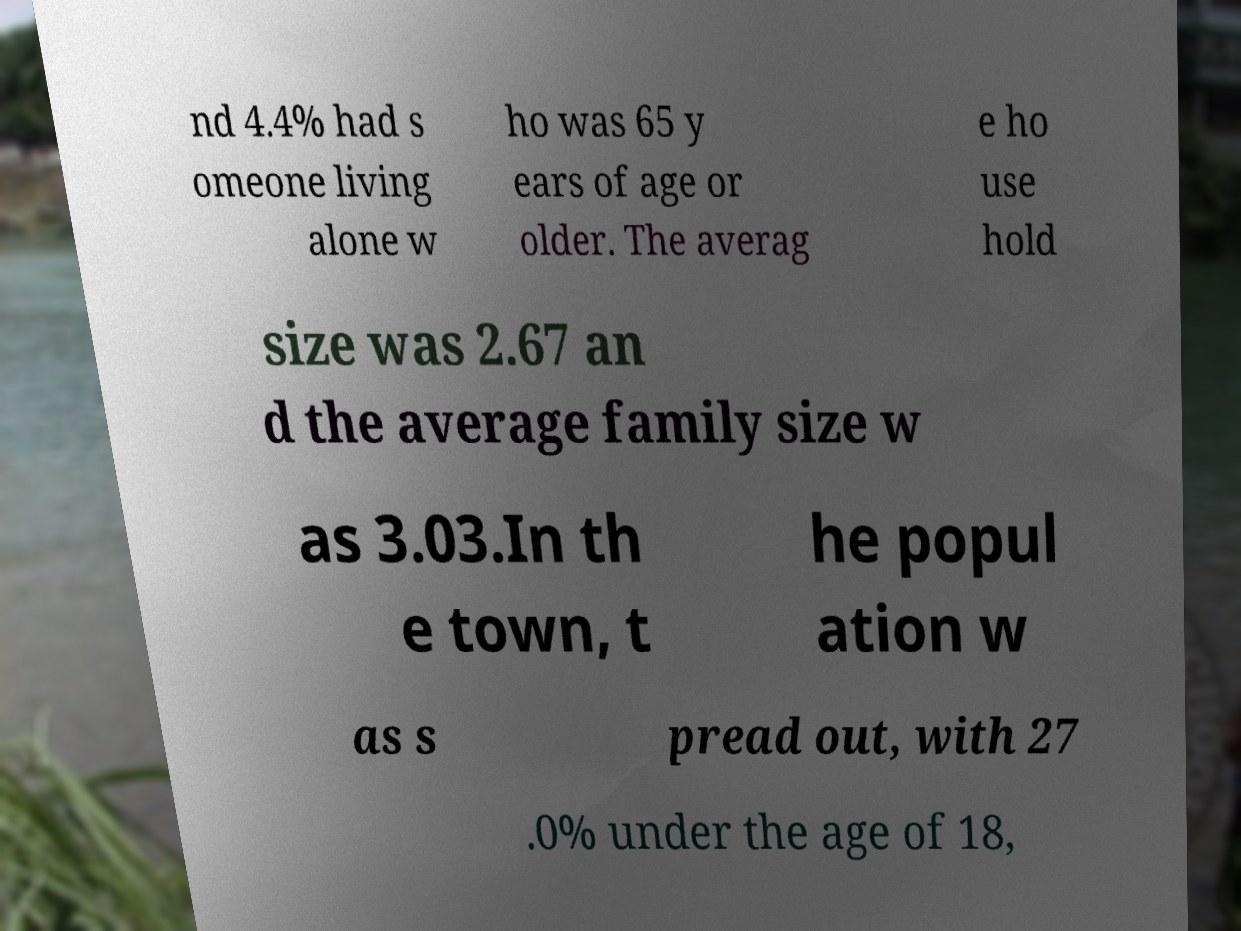For documentation purposes, I need the text within this image transcribed. Could you provide that? nd 4.4% had s omeone living alone w ho was 65 y ears of age or older. The averag e ho use hold size was 2.67 an d the average family size w as 3.03.In th e town, t he popul ation w as s pread out, with 27 .0% under the age of 18, 